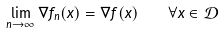Convert formula to latex. <formula><loc_0><loc_0><loc_500><loc_500>\lim _ { n \rightarrow \infty } \nabla f _ { n } ( x ) = \nabla f ( x ) \quad \forall x \in \mathcal { D }</formula> 